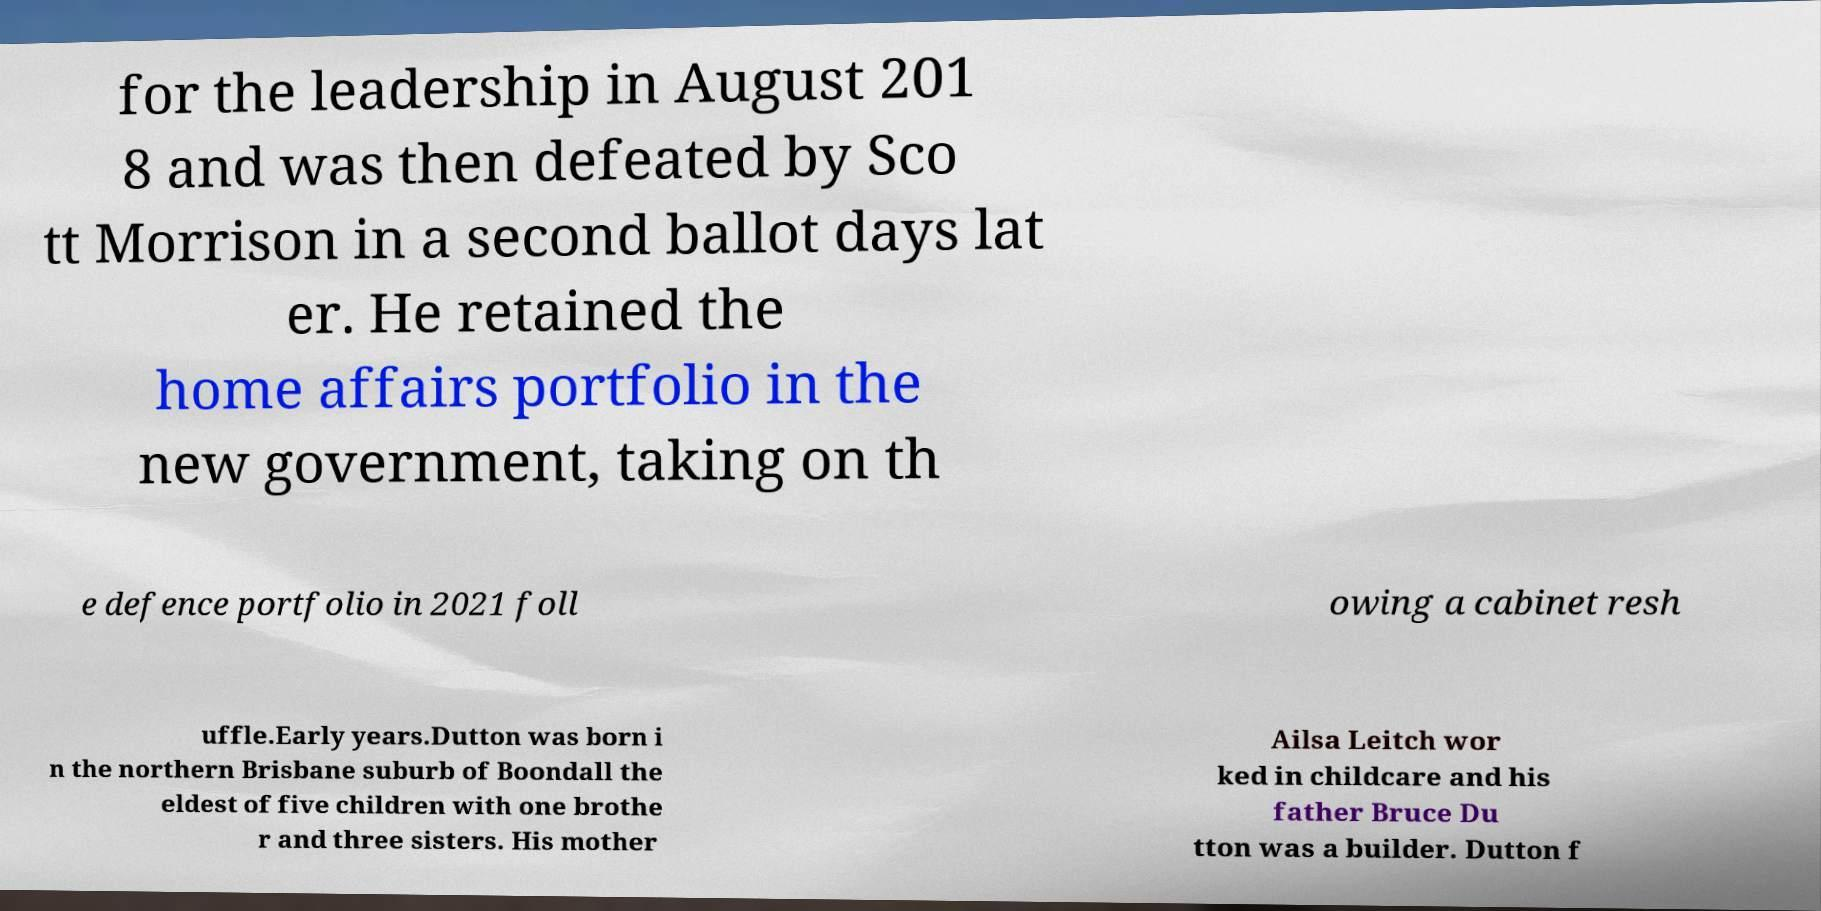I need the written content from this picture converted into text. Can you do that? for the leadership in August 201 8 and was then defeated by Sco tt Morrison in a second ballot days lat er. He retained the home affairs portfolio in the new government, taking on th e defence portfolio in 2021 foll owing a cabinet resh uffle.Early years.Dutton was born i n the northern Brisbane suburb of Boondall the eldest of five children with one brothe r and three sisters. His mother Ailsa Leitch wor ked in childcare and his father Bruce Du tton was a builder. Dutton f 